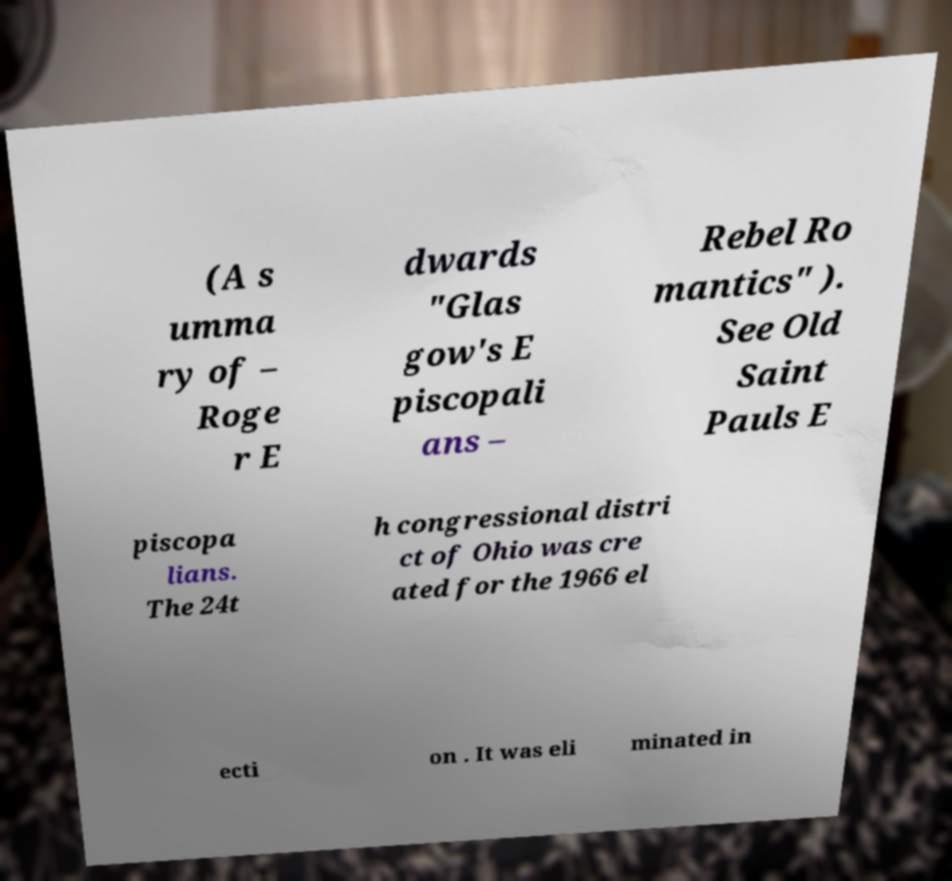Can you read and provide the text displayed in the image?This photo seems to have some interesting text. Can you extract and type it out for me? (A s umma ry of – Roge r E dwards "Glas gow's E piscopali ans – Rebel Ro mantics" ). See Old Saint Pauls E piscopa lians. The 24t h congressional distri ct of Ohio was cre ated for the 1966 el ecti on . It was eli minated in 